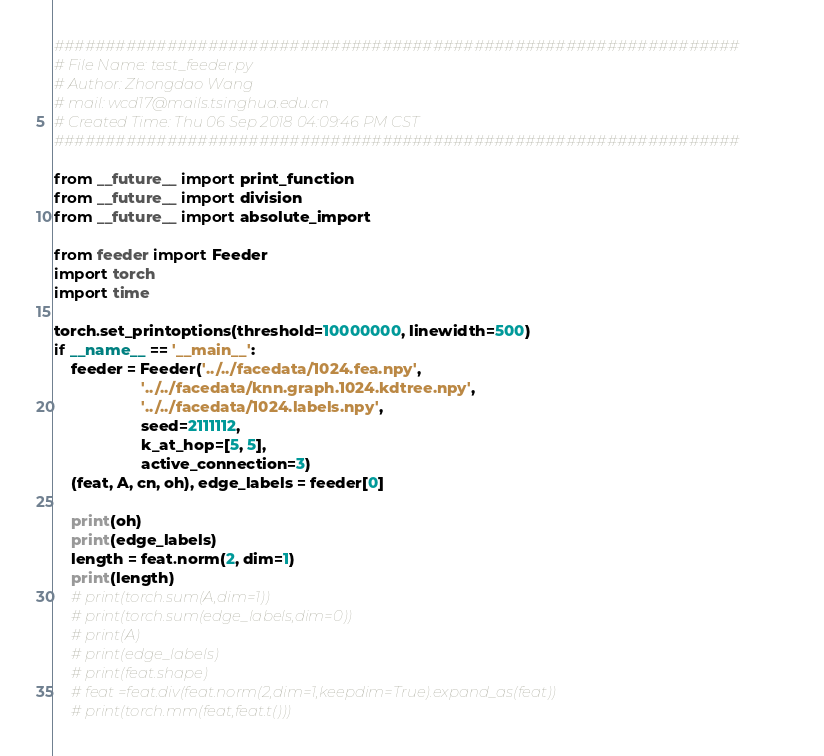<code> <loc_0><loc_0><loc_500><loc_500><_Python_>###################################################################
# File Name: test_feeder.py
# Author: Zhongdao Wang
# mail: wcd17@mails.tsinghua.edu.cn
# Created Time: Thu 06 Sep 2018 04:09:46 PM CST
###################################################################

from __future__ import print_function
from __future__ import division
from __future__ import absolute_import

from feeder import Feeder
import torch
import time

torch.set_printoptions(threshold=10000000, linewidth=500)
if __name__ == '__main__':
    feeder = Feeder('../../facedata/1024.fea.npy',
                    '../../facedata/knn.graph.1024.kdtree.npy',
                    '../../facedata/1024.labels.npy',
                    seed=2111112,
                    k_at_hop=[5, 5],
                    active_connection=3)
    (feat, A, cn, oh), edge_labels = feeder[0]

    print(oh)
    print(edge_labels)
    length = feat.norm(2, dim=1)
    print(length)
    # print(torch.sum(A,dim=1))
    # print(torch.sum(edge_labels,dim=0))
    # print(A)
    # print(edge_labels)
    # print(feat.shape)
    # feat =feat.div(feat.norm(2,dim=1,keepdim=True).expand_as(feat))
    # print(torch.mm(feat,feat.t()))
</code> 